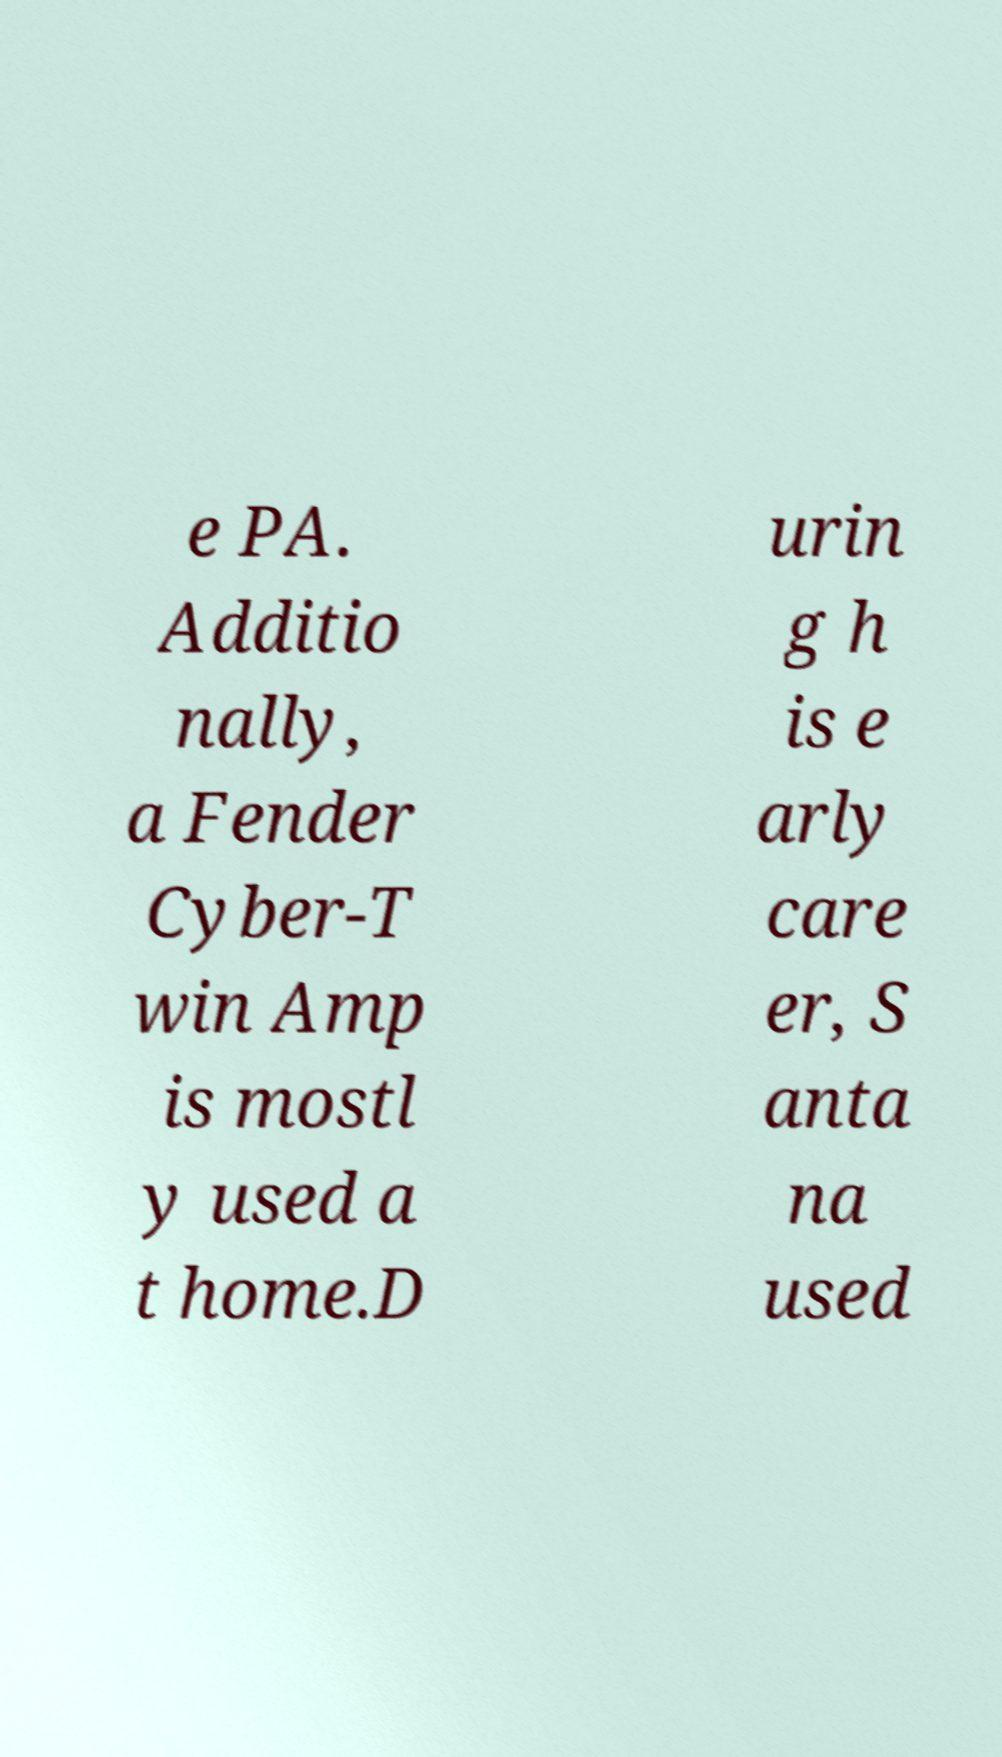Please identify and transcribe the text found in this image. e PA. Additio nally, a Fender Cyber-T win Amp is mostl y used a t home.D urin g h is e arly care er, S anta na used 